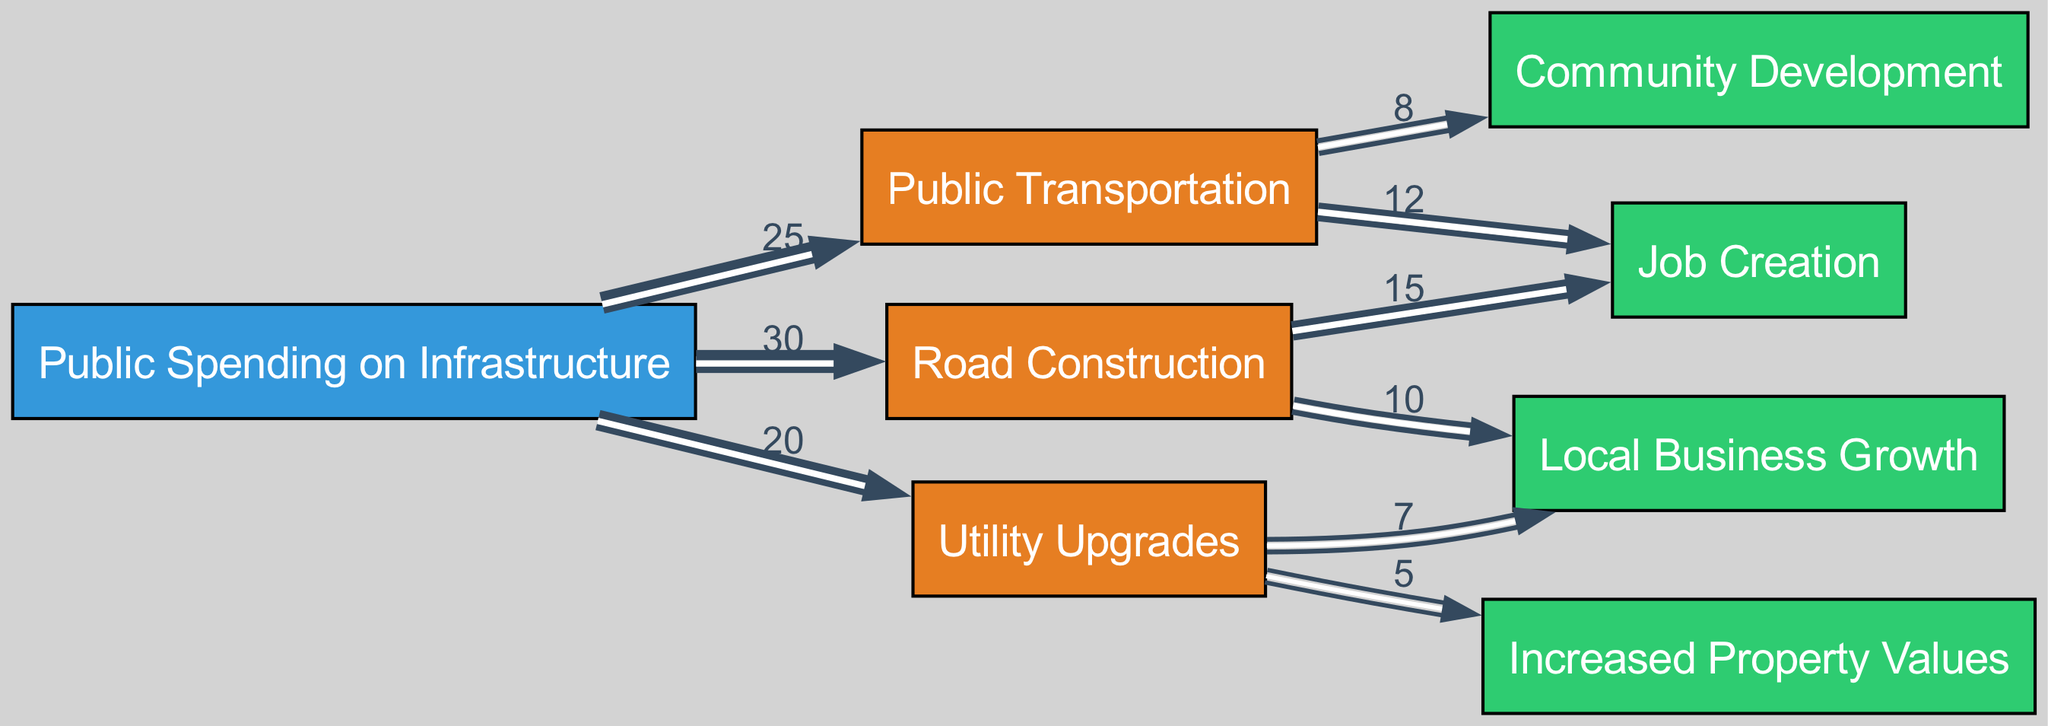What is the total public spending on infrastructure shown in the diagram? The diagram displays individual project spending, which sums up to 30 (Road Construction) + 25 (Public Transportation) + 20 (Utility Upgrades) = 75.
Answer: 75 Which infrastructure project has the highest impact on job creation? The diagram indicates that Road Construction contributes 15 to Job Creation, while Public Transportation contributes 12. Therefore, Road Construction has the highest impact on job creation.
Answer: Road Construction How many nodes are listed in the diagram? The diagram includes 8 nodes: 1 source (Public Spending on Infrastructure), 3 projects (Road Construction, Public Transportation, Utility Upgrades), and 4 impacts (Job Creation, Local Business Growth, Increased Property Values, Community Development), which totals to 8.
Answer: 8 What is the value of the link from Utility Upgrades to Local Business Growth? The link from Utility Upgrades to Local Business Growth has a specific value of 7 assigned in the diagram.
Answer: 7 Which project contributes the least to increased property values? The diagram shows that the only project affecting Increased Property Values is Utility Upgrades, contributing a value of 5. Therefore, it is the least contributing project for that indicator.
Answer: Utility Upgrades What is the total impact value on Local Business Growth from all projects? For Local Business Growth, Road Construction contributes 10 and Utility Upgrades contributes 7. Therefore, the total impact value on Local Business Growth is 10 + 7 = 17.
Answer: 17 Is there any project that affects both job creation and local business growth? Yes, the diagram shows that Road Construction affects both Job Creation (value of 15) and Local Business Growth (value of 10).
Answer: Yes What percentage of the total public spending is allocated to Public Transportation? The value for Public Transportation is 25. The total public spending calculated earlier is 75. Thus, the percentage is (25/75) * 100 = 33.3%.
Answer: 33.3% What is the combined impact on community development through all projects? The diagram shows that the only contribution to Community Development is from Public Transportation, which has a value of 8. Hence, the combined impact is simply that value.
Answer: 8 